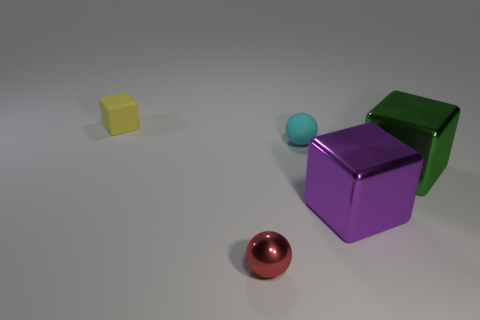Is the purple object made of the same material as the tiny yellow cube?
Keep it short and to the point. No. How many other things are made of the same material as the large green block?
Give a very brief answer. 2. What number of things are both to the right of the yellow thing and behind the tiny red sphere?
Provide a succinct answer. 3. What color is the small matte block?
Give a very brief answer. Yellow. There is a tiny cyan thing that is the same shape as the small red thing; what material is it?
Ensure brevity in your answer.  Rubber. What shape is the big object to the right of the big shiny cube that is to the left of the green metal thing?
Offer a very short reply. Cube. What is the shape of the small thing that is the same material as the purple cube?
Your response must be concise. Sphere. What number of other things are there of the same shape as the small metallic object?
Your response must be concise. 1. There is a rubber object that is right of the yellow object; is it the same size as the yellow object?
Make the answer very short. Yes. Is the number of red metal objects in front of the matte ball greater than the number of small matte cylinders?
Provide a succinct answer. Yes. 